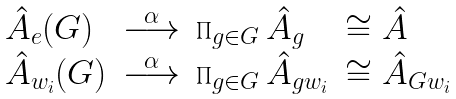<formula> <loc_0><loc_0><loc_500><loc_500>\begin{array} { l l l l } \hat { A } _ { e } ( G ) & \overset { \alpha } { \longrightarrow } & \prod _ { g \in G } \hat { A } _ { g } & \cong \hat { A } \\ \hat { A } _ { w _ { i } } ( G ) & \overset { \alpha } { \longrightarrow } & \prod _ { g \in G } \hat { A } _ { g w _ { i } } & \cong \hat { A } _ { G w _ { i } } \\ \end{array}</formula> 